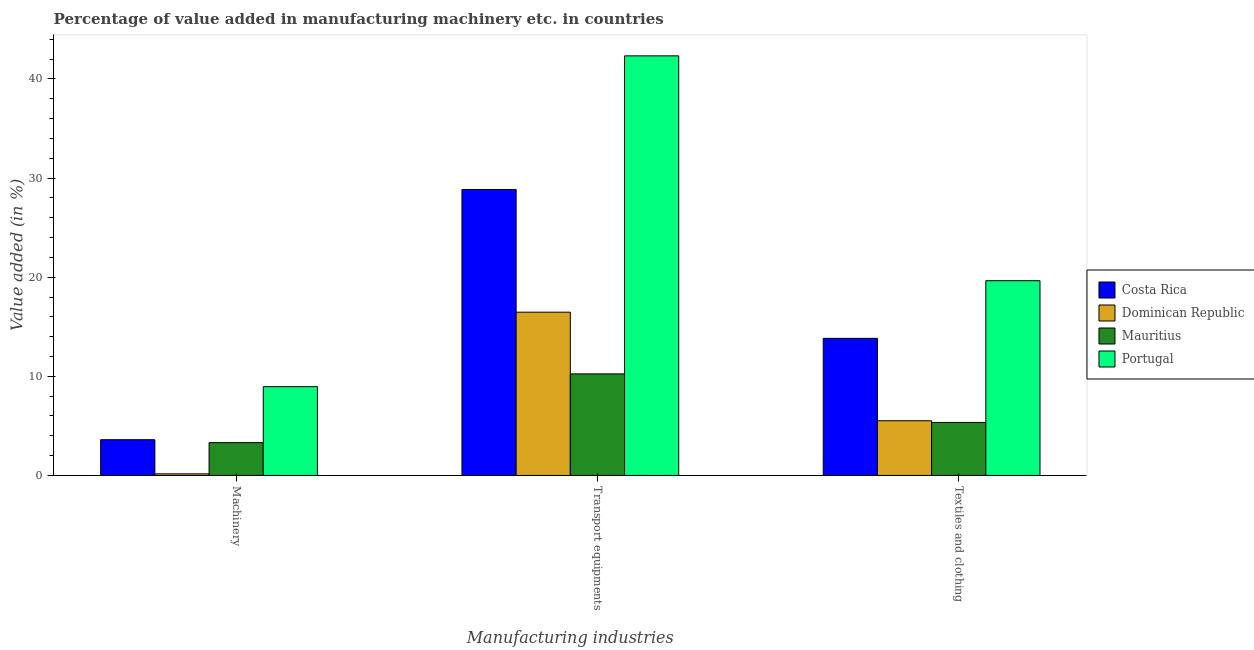How many groups of bars are there?
Offer a very short reply. 3. Are the number of bars on each tick of the X-axis equal?
Your answer should be compact. Yes. How many bars are there on the 1st tick from the left?
Your answer should be compact. 4. What is the label of the 3rd group of bars from the left?
Keep it short and to the point. Textiles and clothing. What is the value added in manufacturing machinery in Costa Rica?
Keep it short and to the point. 3.61. Across all countries, what is the maximum value added in manufacturing machinery?
Keep it short and to the point. 8.96. Across all countries, what is the minimum value added in manufacturing transport equipments?
Ensure brevity in your answer.  10.25. In which country was the value added in manufacturing transport equipments minimum?
Keep it short and to the point. Mauritius. What is the total value added in manufacturing transport equipments in the graph?
Your response must be concise. 97.91. What is the difference between the value added in manufacturing transport equipments in Dominican Republic and that in Costa Rica?
Ensure brevity in your answer.  -12.38. What is the difference between the value added in manufacturing textile and clothing in Mauritius and the value added in manufacturing machinery in Dominican Republic?
Your answer should be compact. 5.19. What is the average value added in manufacturing machinery per country?
Keep it short and to the point. 4.01. What is the difference between the value added in manufacturing machinery and value added in manufacturing textile and clothing in Costa Rica?
Offer a very short reply. -10.23. What is the ratio of the value added in manufacturing transport equipments in Dominican Republic to that in Portugal?
Provide a succinct answer. 0.39. Is the value added in manufacturing textile and clothing in Costa Rica less than that in Mauritius?
Offer a very short reply. No. Is the difference between the value added in manufacturing machinery in Portugal and Dominican Republic greater than the difference between the value added in manufacturing textile and clothing in Portugal and Dominican Republic?
Provide a succinct answer. No. What is the difference between the highest and the second highest value added in manufacturing machinery?
Your response must be concise. 5.35. What is the difference between the highest and the lowest value added in manufacturing machinery?
Provide a short and direct response. 8.8. In how many countries, is the value added in manufacturing machinery greater than the average value added in manufacturing machinery taken over all countries?
Your response must be concise. 1. Is the sum of the value added in manufacturing transport equipments in Mauritius and Dominican Republic greater than the maximum value added in manufacturing textile and clothing across all countries?
Offer a very short reply. Yes. What does the 2nd bar from the left in Transport equipments represents?
Provide a short and direct response. Dominican Republic. What does the 2nd bar from the right in Textiles and clothing represents?
Your response must be concise. Mauritius. Are all the bars in the graph horizontal?
Offer a very short reply. No. How many countries are there in the graph?
Your answer should be very brief. 4. What is the difference between two consecutive major ticks on the Y-axis?
Provide a succinct answer. 10. Does the graph contain any zero values?
Make the answer very short. No. How are the legend labels stacked?
Make the answer very short. Vertical. What is the title of the graph?
Provide a short and direct response. Percentage of value added in manufacturing machinery etc. in countries. What is the label or title of the X-axis?
Offer a terse response. Manufacturing industries. What is the label or title of the Y-axis?
Make the answer very short. Value added (in %). What is the Value added (in %) of Costa Rica in Machinery?
Make the answer very short. 3.61. What is the Value added (in %) of Dominican Republic in Machinery?
Your response must be concise. 0.16. What is the Value added (in %) of Mauritius in Machinery?
Your answer should be compact. 3.31. What is the Value added (in %) in Portugal in Machinery?
Provide a short and direct response. 8.96. What is the Value added (in %) in Costa Rica in Transport equipments?
Provide a succinct answer. 28.85. What is the Value added (in %) in Dominican Republic in Transport equipments?
Keep it short and to the point. 16.47. What is the Value added (in %) of Mauritius in Transport equipments?
Your answer should be very brief. 10.25. What is the Value added (in %) in Portugal in Transport equipments?
Give a very brief answer. 42.34. What is the Value added (in %) in Costa Rica in Textiles and clothing?
Your answer should be compact. 13.83. What is the Value added (in %) in Dominican Republic in Textiles and clothing?
Offer a terse response. 5.52. What is the Value added (in %) in Mauritius in Textiles and clothing?
Offer a terse response. 5.35. What is the Value added (in %) in Portugal in Textiles and clothing?
Your answer should be very brief. 19.65. Across all Manufacturing industries, what is the maximum Value added (in %) in Costa Rica?
Provide a succinct answer. 28.85. Across all Manufacturing industries, what is the maximum Value added (in %) of Dominican Republic?
Keep it short and to the point. 16.47. Across all Manufacturing industries, what is the maximum Value added (in %) in Mauritius?
Provide a short and direct response. 10.25. Across all Manufacturing industries, what is the maximum Value added (in %) in Portugal?
Keep it short and to the point. 42.34. Across all Manufacturing industries, what is the minimum Value added (in %) of Costa Rica?
Provide a short and direct response. 3.61. Across all Manufacturing industries, what is the minimum Value added (in %) of Dominican Republic?
Your answer should be compact. 0.16. Across all Manufacturing industries, what is the minimum Value added (in %) of Mauritius?
Your answer should be very brief. 3.31. Across all Manufacturing industries, what is the minimum Value added (in %) of Portugal?
Your answer should be compact. 8.96. What is the total Value added (in %) in Costa Rica in the graph?
Your answer should be very brief. 46.29. What is the total Value added (in %) of Dominican Republic in the graph?
Provide a short and direct response. 22.15. What is the total Value added (in %) in Mauritius in the graph?
Your response must be concise. 18.9. What is the total Value added (in %) in Portugal in the graph?
Make the answer very short. 70.94. What is the difference between the Value added (in %) in Costa Rica in Machinery and that in Transport equipments?
Your response must be concise. -25.25. What is the difference between the Value added (in %) of Dominican Republic in Machinery and that in Transport equipments?
Your answer should be very brief. -16.31. What is the difference between the Value added (in %) of Mauritius in Machinery and that in Transport equipments?
Provide a short and direct response. -6.94. What is the difference between the Value added (in %) of Portugal in Machinery and that in Transport equipments?
Keep it short and to the point. -33.38. What is the difference between the Value added (in %) in Costa Rica in Machinery and that in Textiles and clothing?
Offer a terse response. -10.23. What is the difference between the Value added (in %) of Dominican Republic in Machinery and that in Textiles and clothing?
Provide a succinct answer. -5.36. What is the difference between the Value added (in %) of Mauritius in Machinery and that in Textiles and clothing?
Offer a very short reply. -2.04. What is the difference between the Value added (in %) in Portugal in Machinery and that in Textiles and clothing?
Keep it short and to the point. -10.69. What is the difference between the Value added (in %) of Costa Rica in Transport equipments and that in Textiles and clothing?
Ensure brevity in your answer.  15.02. What is the difference between the Value added (in %) of Dominican Republic in Transport equipments and that in Textiles and clothing?
Offer a very short reply. 10.95. What is the difference between the Value added (in %) in Mauritius in Transport equipments and that in Textiles and clothing?
Offer a very short reply. 4.9. What is the difference between the Value added (in %) in Portugal in Transport equipments and that in Textiles and clothing?
Keep it short and to the point. 22.69. What is the difference between the Value added (in %) in Costa Rica in Machinery and the Value added (in %) in Dominican Republic in Transport equipments?
Keep it short and to the point. -12.87. What is the difference between the Value added (in %) of Costa Rica in Machinery and the Value added (in %) of Mauritius in Transport equipments?
Provide a succinct answer. -6.64. What is the difference between the Value added (in %) in Costa Rica in Machinery and the Value added (in %) in Portugal in Transport equipments?
Give a very brief answer. -38.73. What is the difference between the Value added (in %) of Dominican Republic in Machinery and the Value added (in %) of Mauritius in Transport equipments?
Give a very brief answer. -10.09. What is the difference between the Value added (in %) of Dominican Republic in Machinery and the Value added (in %) of Portugal in Transport equipments?
Provide a short and direct response. -42.17. What is the difference between the Value added (in %) in Mauritius in Machinery and the Value added (in %) in Portugal in Transport equipments?
Your response must be concise. -39.03. What is the difference between the Value added (in %) in Costa Rica in Machinery and the Value added (in %) in Dominican Republic in Textiles and clothing?
Offer a terse response. -1.91. What is the difference between the Value added (in %) in Costa Rica in Machinery and the Value added (in %) in Mauritius in Textiles and clothing?
Your answer should be very brief. -1.74. What is the difference between the Value added (in %) in Costa Rica in Machinery and the Value added (in %) in Portugal in Textiles and clothing?
Make the answer very short. -16.04. What is the difference between the Value added (in %) of Dominican Republic in Machinery and the Value added (in %) of Mauritius in Textiles and clothing?
Provide a short and direct response. -5.19. What is the difference between the Value added (in %) of Dominican Republic in Machinery and the Value added (in %) of Portugal in Textiles and clothing?
Keep it short and to the point. -19.49. What is the difference between the Value added (in %) in Mauritius in Machinery and the Value added (in %) in Portugal in Textiles and clothing?
Offer a very short reply. -16.34. What is the difference between the Value added (in %) in Costa Rica in Transport equipments and the Value added (in %) in Dominican Republic in Textiles and clothing?
Give a very brief answer. 23.33. What is the difference between the Value added (in %) in Costa Rica in Transport equipments and the Value added (in %) in Mauritius in Textiles and clothing?
Ensure brevity in your answer.  23.51. What is the difference between the Value added (in %) of Costa Rica in Transport equipments and the Value added (in %) of Portugal in Textiles and clothing?
Your answer should be very brief. 9.21. What is the difference between the Value added (in %) in Dominican Republic in Transport equipments and the Value added (in %) in Mauritius in Textiles and clothing?
Offer a very short reply. 11.13. What is the difference between the Value added (in %) in Dominican Republic in Transport equipments and the Value added (in %) in Portugal in Textiles and clothing?
Give a very brief answer. -3.17. What is the difference between the Value added (in %) of Mauritius in Transport equipments and the Value added (in %) of Portugal in Textiles and clothing?
Provide a succinct answer. -9.4. What is the average Value added (in %) of Costa Rica per Manufacturing industries?
Offer a terse response. 15.43. What is the average Value added (in %) of Dominican Republic per Manufacturing industries?
Offer a very short reply. 7.38. What is the average Value added (in %) in Mauritius per Manufacturing industries?
Offer a terse response. 6.3. What is the average Value added (in %) of Portugal per Manufacturing industries?
Keep it short and to the point. 23.65. What is the difference between the Value added (in %) in Costa Rica and Value added (in %) in Dominican Republic in Machinery?
Give a very brief answer. 3.44. What is the difference between the Value added (in %) of Costa Rica and Value added (in %) of Mauritius in Machinery?
Your answer should be very brief. 0.3. What is the difference between the Value added (in %) in Costa Rica and Value added (in %) in Portugal in Machinery?
Offer a very short reply. -5.35. What is the difference between the Value added (in %) of Dominican Republic and Value added (in %) of Mauritius in Machinery?
Ensure brevity in your answer.  -3.15. What is the difference between the Value added (in %) of Dominican Republic and Value added (in %) of Portugal in Machinery?
Provide a short and direct response. -8.8. What is the difference between the Value added (in %) in Mauritius and Value added (in %) in Portugal in Machinery?
Your answer should be very brief. -5.65. What is the difference between the Value added (in %) in Costa Rica and Value added (in %) in Dominican Republic in Transport equipments?
Offer a terse response. 12.38. What is the difference between the Value added (in %) of Costa Rica and Value added (in %) of Mauritius in Transport equipments?
Your answer should be very brief. 18.6. What is the difference between the Value added (in %) in Costa Rica and Value added (in %) in Portugal in Transport equipments?
Provide a short and direct response. -13.48. What is the difference between the Value added (in %) in Dominican Republic and Value added (in %) in Mauritius in Transport equipments?
Provide a succinct answer. 6.23. What is the difference between the Value added (in %) in Dominican Republic and Value added (in %) in Portugal in Transport equipments?
Give a very brief answer. -25.86. What is the difference between the Value added (in %) in Mauritius and Value added (in %) in Portugal in Transport equipments?
Keep it short and to the point. -32.09. What is the difference between the Value added (in %) in Costa Rica and Value added (in %) in Dominican Republic in Textiles and clothing?
Make the answer very short. 8.31. What is the difference between the Value added (in %) of Costa Rica and Value added (in %) of Mauritius in Textiles and clothing?
Keep it short and to the point. 8.48. What is the difference between the Value added (in %) of Costa Rica and Value added (in %) of Portugal in Textiles and clothing?
Your answer should be compact. -5.82. What is the difference between the Value added (in %) of Dominican Republic and Value added (in %) of Mauritius in Textiles and clothing?
Give a very brief answer. 0.17. What is the difference between the Value added (in %) of Dominican Republic and Value added (in %) of Portugal in Textiles and clothing?
Your answer should be very brief. -14.13. What is the difference between the Value added (in %) in Mauritius and Value added (in %) in Portugal in Textiles and clothing?
Offer a terse response. -14.3. What is the ratio of the Value added (in %) of Costa Rica in Machinery to that in Transport equipments?
Make the answer very short. 0.12. What is the ratio of the Value added (in %) in Dominican Republic in Machinery to that in Transport equipments?
Ensure brevity in your answer.  0.01. What is the ratio of the Value added (in %) in Mauritius in Machinery to that in Transport equipments?
Make the answer very short. 0.32. What is the ratio of the Value added (in %) in Portugal in Machinery to that in Transport equipments?
Provide a succinct answer. 0.21. What is the ratio of the Value added (in %) of Costa Rica in Machinery to that in Textiles and clothing?
Make the answer very short. 0.26. What is the ratio of the Value added (in %) in Dominican Republic in Machinery to that in Textiles and clothing?
Make the answer very short. 0.03. What is the ratio of the Value added (in %) in Mauritius in Machinery to that in Textiles and clothing?
Keep it short and to the point. 0.62. What is the ratio of the Value added (in %) of Portugal in Machinery to that in Textiles and clothing?
Your answer should be very brief. 0.46. What is the ratio of the Value added (in %) in Costa Rica in Transport equipments to that in Textiles and clothing?
Provide a succinct answer. 2.09. What is the ratio of the Value added (in %) in Dominican Republic in Transport equipments to that in Textiles and clothing?
Make the answer very short. 2.98. What is the ratio of the Value added (in %) of Mauritius in Transport equipments to that in Textiles and clothing?
Offer a very short reply. 1.92. What is the ratio of the Value added (in %) of Portugal in Transport equipments to that in Textiles and clothing?
Provide a succinct answer. 2.15. What is the difference between the highest and the second highest Value added (in %) of Costa Rica?
Offer a terse response. 15.02. What is the difference between the highest and the second highest Value added (in %) of Dominican Republic?
Your response must be concise. 10.95. What is the difference between the highest and the second highest Value added (in %) in Mauritius?
Your answer should be very brief. 4.9. What is the difference between the highest and the second highest Value added (in %) in Portugal?
Give a very brief answer. 22.69. What is the difference between the highest and the lowest Value added (in %) of Costa Rica?
Provide a short and direct response. 25.25. What is the difference between the highest and the lowest Value added (in %) of Dominican Republic?
Offer a very short reply. 16.31. What is the difference between the highest and the lowest Value added (in %) in Mauritius?
Your answer should be compact. 6.94. What is the difference between the highest and the lowest Value added (in %) in Portugal?
Offer a terse response. 33.38. 